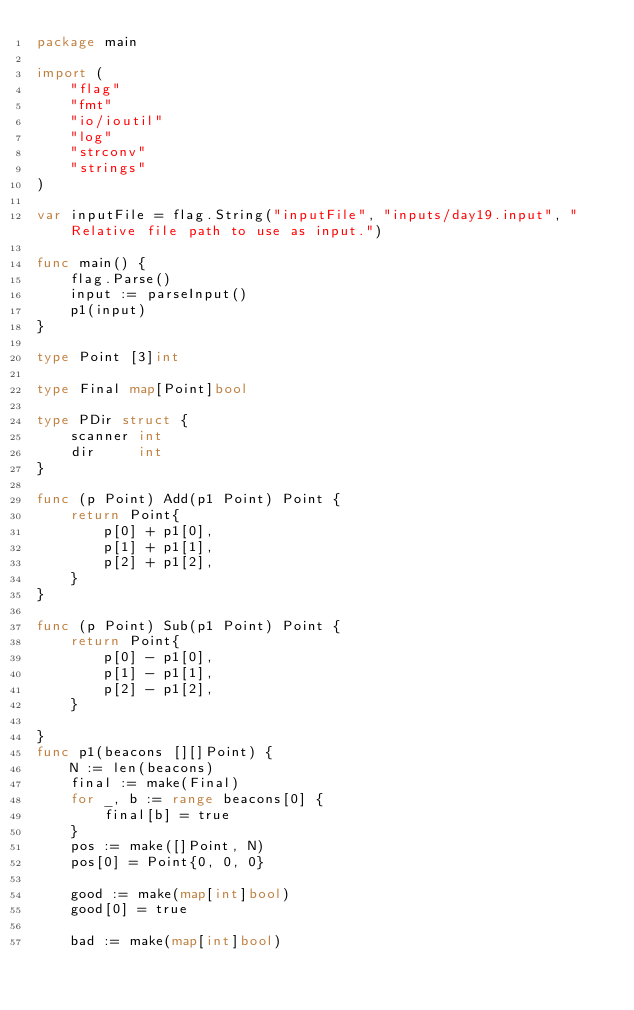<code> <loc_0><loc_0><loc_500><loc_500><_Go_>package main

import (
	"flag"
	"fmt"
	"io/ioutil"
	"log"
	"strconv"
	"strings"
)

var inputFile = flag.String("inputFile", "inputs/day19.input", "Relative file path to use as input.")

func main() {
	flag.Parse()
	input := parseInput()
	p1(input)
}

type Point [3]int

type Final map[Point]bool

type PDir struct {
	scanner int
	dir     int
}

func (p Point) Add(p1 Point) Point {
	return Point{
		p[0] + p1[0],
		p[1] + p1[1],
		p[2] + p1[2],
	}
}

func (p Point) Sub(p1 Point) Point {
	return Point{
		p[0] - p1[0],
		p[1] - p1[1],
		p[2] - p1[2],
	}

}
func p1(beacons [][]Point) {
	N := len(beacons)
	final := make(Final)
	for _, b := range beacons[0] {
		final[b] = true
	}
	pos := make([]Point, N)
	pos[0] = Point{0, 0, 0}

	good := make(map[int]bool)
	good[0] = true

	bad := make(map[int]bool)</code> 